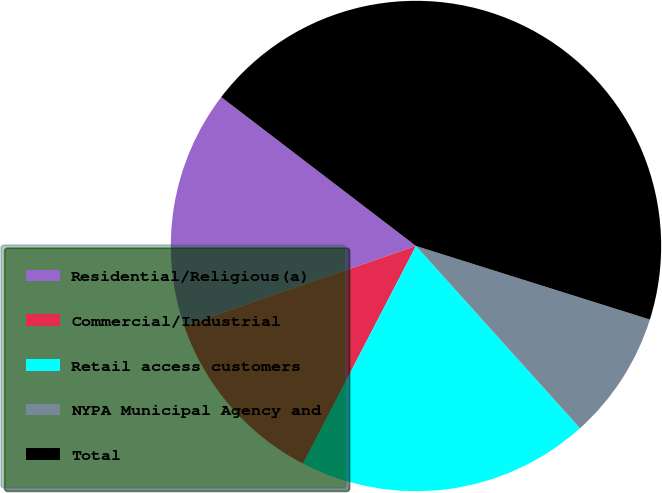Convert chart. <chart><loc_0><loc_0><loc_500><loc_500><pie_chart><fcel>Residential/Religious(a)<fcel>Commercial/Industrial<fcel>Retail access customers<fcel>NYPA Municipal Agency and<fcel>Total<nl><fcel>15.68%<fcel>12.09%<fcel>19.28%<fcel>8.49%<fcel>44.46%<nl></chart> 